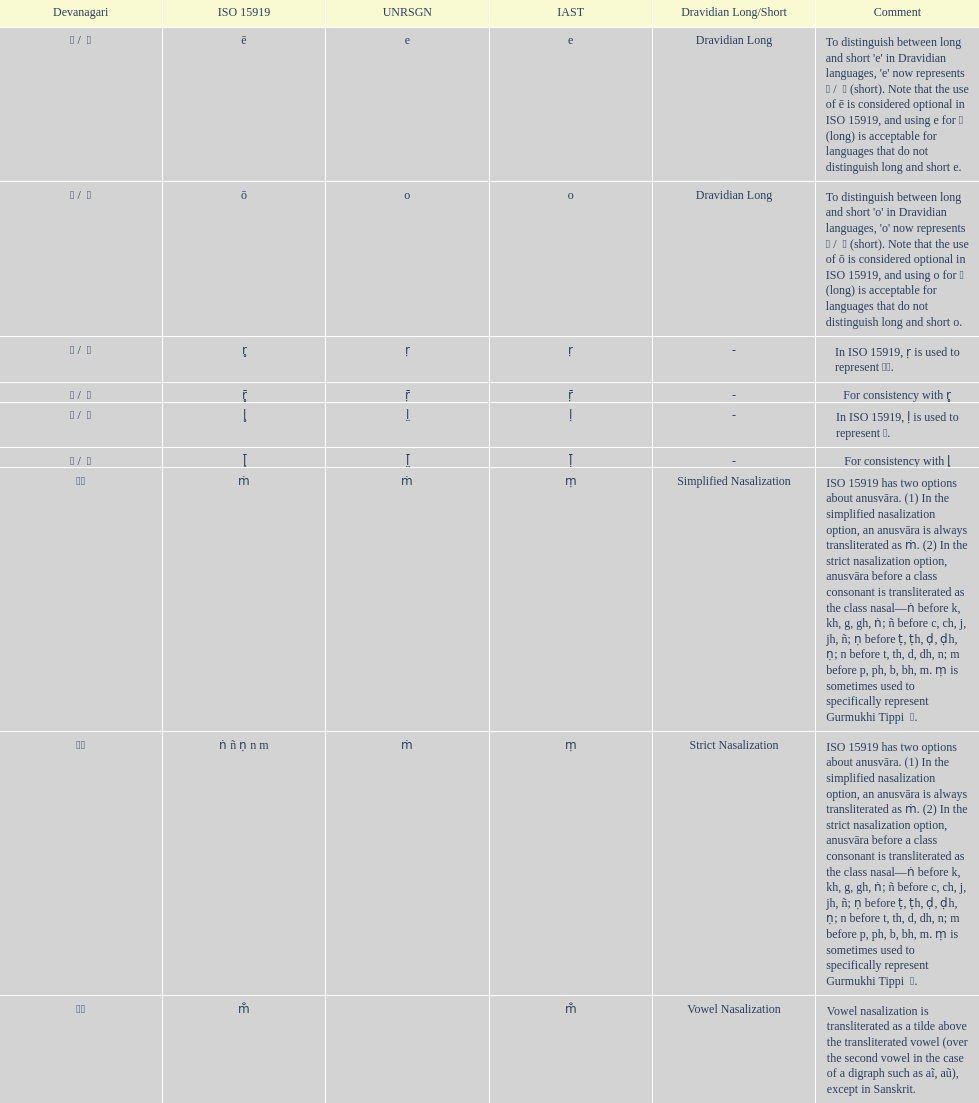Which devanagari transliteration is mentioned at the beginning of the table? ए / े. 